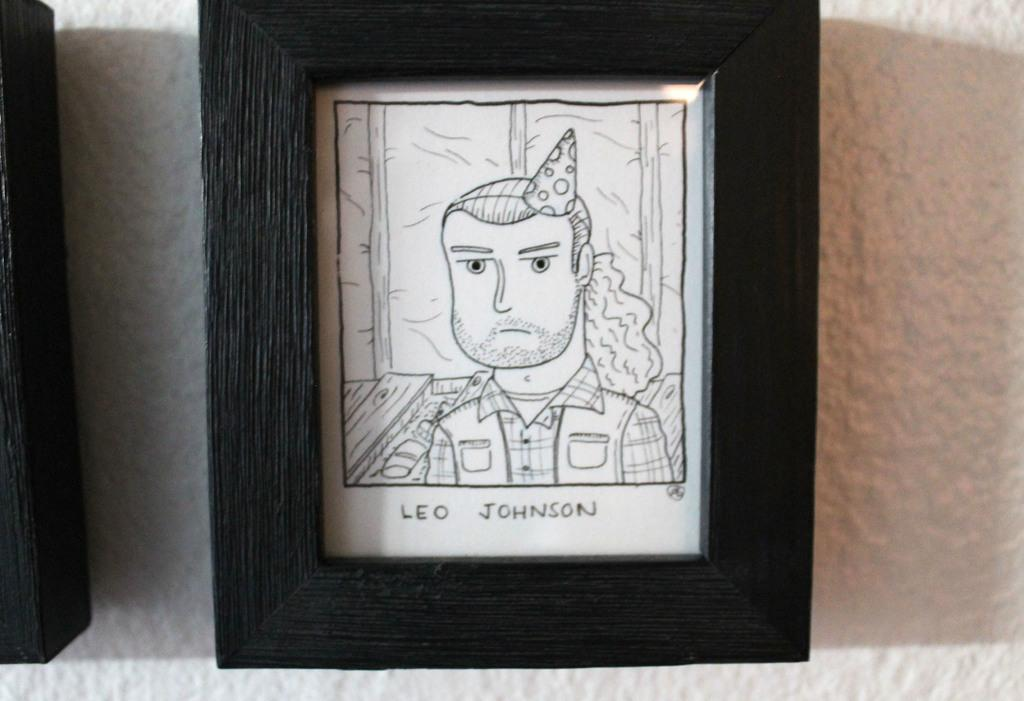<image>
Write a terse but informative summary of the picture. a character on the front of a photo with the name Leo 